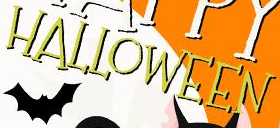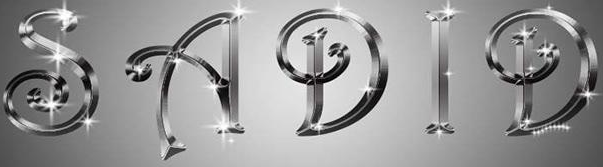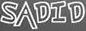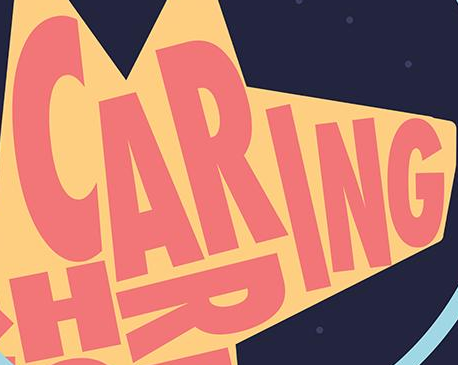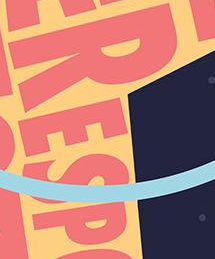What text appears in these images from left to right, separated by a semicolon? HALLOWEEN; SADID; SADID; CARING; RESP 